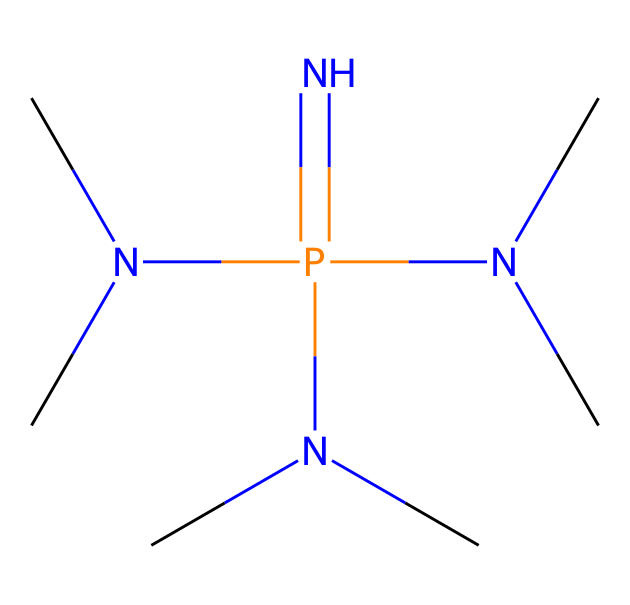What is the total number of nitrogen atoms in this phosphazene base? The SMILES representation indicates the structure includes three nitrogen atoms (N) that are part of the phosphazene framework. Each 'N' in the SMILES corresponds to one nitrogen atom.
Answer: 3 How many methyl groups are attached to the nitrogen atoms in this chemical? Looking at the SMILES, there are three instances of 'N(C)C', which denote that each nitrogen atom is attached to two methyl groups (since 'N(C)C' indicates a nitrogen bonded to two carbons). Therefore, with three nitrogen atoms present, this results in six methyl groups total.
Answer: 6 Is this compound more basic or acidic? Phosphazene bases are characterized by their high basicity due to the presence of nitrogen with lone pairs that can accept protons. Given its structure as a phosphazene, it is designed to be a superb base, indicating it is more basic.
Answer: basic What type of bonding is primarily featured in this compound? Analyzing the structure, the main types of bonding present are covalent bonds between the nitrogen atoms and the phosphorus atom, as well as between the nitrogen atoms and the attached methyl groups. Phosphazene compounds typically exhibit covalent bonding characteristics.
Answer: covalent What main element is at the center of the chemical structure? The structure is based around a central phosphorus (P) atom, which connects to the nitrogen atoms, making it the main element in the chemical nature of this compound.
Answer: phosphorus Can you identify the type of this chemical compound? The presence of phosphorus and multiple nitrogen functionalities in the structure classifies this compound as a phosphazene base, belonging to the category of superbases.
Answer: phosphazene base 